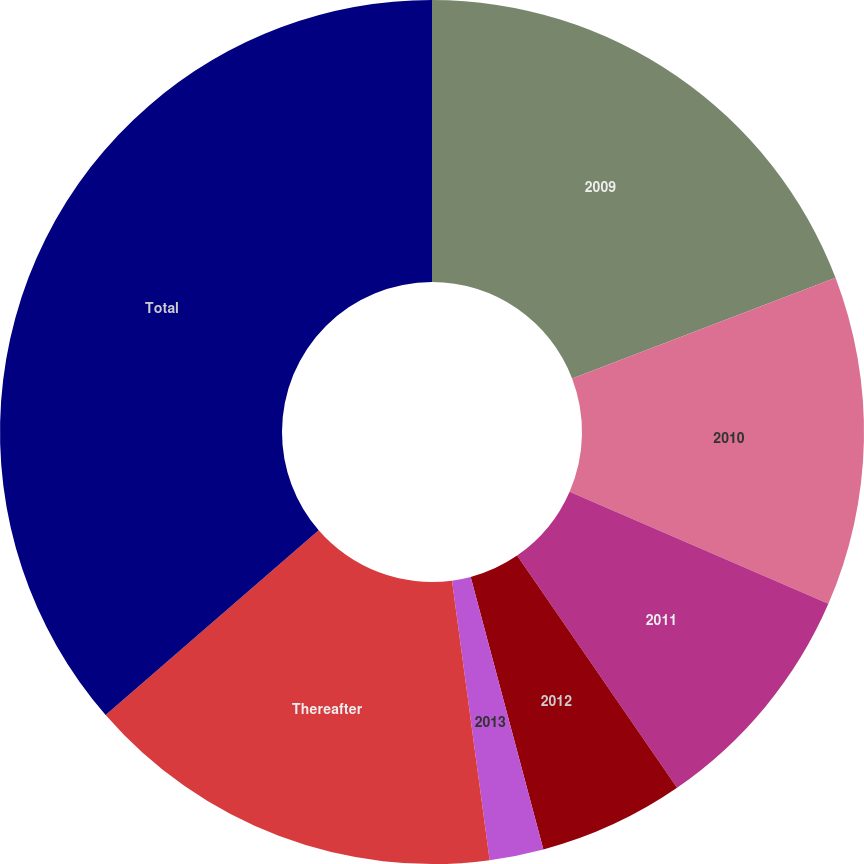Convert chart to OTSL. <chart><loc_0><loc_0><loc_500><loc_500><pie_chart><fcel>2009<fcel>2010<fcel>2011<fcel>2012<fcel>2013<fcel>Thereafter<fcel>Total<nl><fcel>19.19%<fcel>12.32%<fcel>8.89%<fcel>5.45%<fcel>2.02%<fcel>15.76%<fcel>36.37%<nl></chart> 